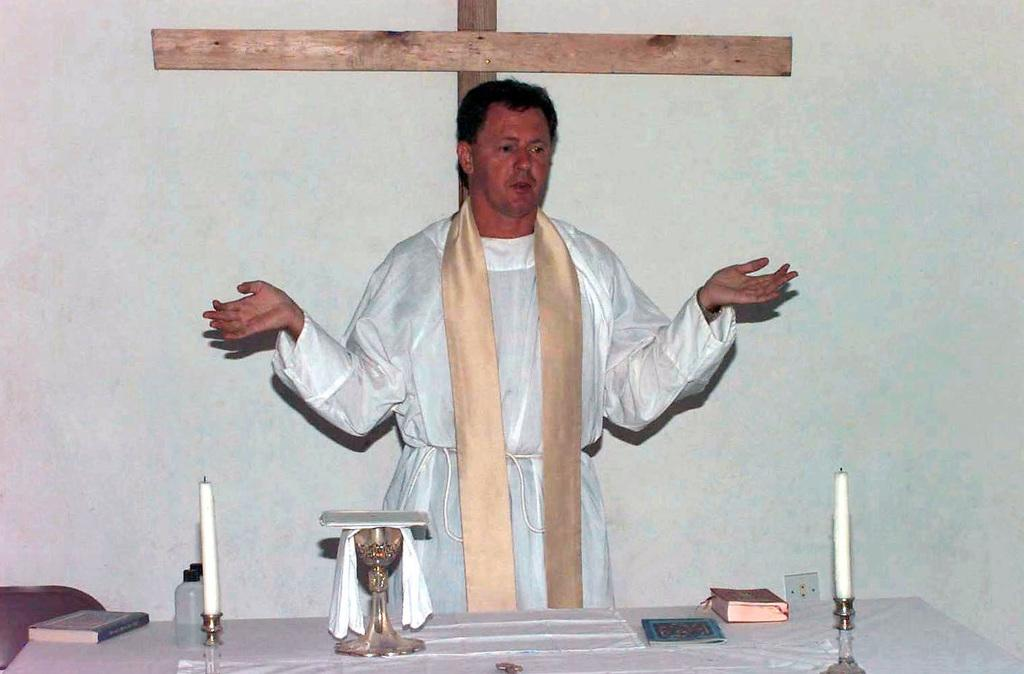Who is the main subject in the image? There is a priest in the center of the image. What is in front of the priest? There is a table in front of the priest. What items can be seen on the table? There are candles and books on the table. What type of polish is the priest applying to the kitten in the image? There is no kitten present in the image, and the priest is not applying any polish. 